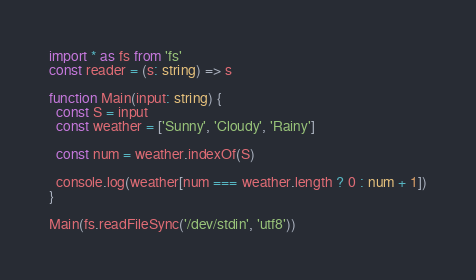<code> <loc_0><loc_0><loc_500><loc_500><_TypeScript_>import * as fs from 'fs'
const reader = (s: string) => s

function Main(input: string) {
  const S = input
  const weather = ['Sunny', 'Cloudy', 'Rainy']

  const num = weather.indexOf(S)

  console.log(weather[num === weather.length ? 0 : num + 1])
}

Main(fs.readFileSync('/dev/stdin', 'utf8'))
</code> 